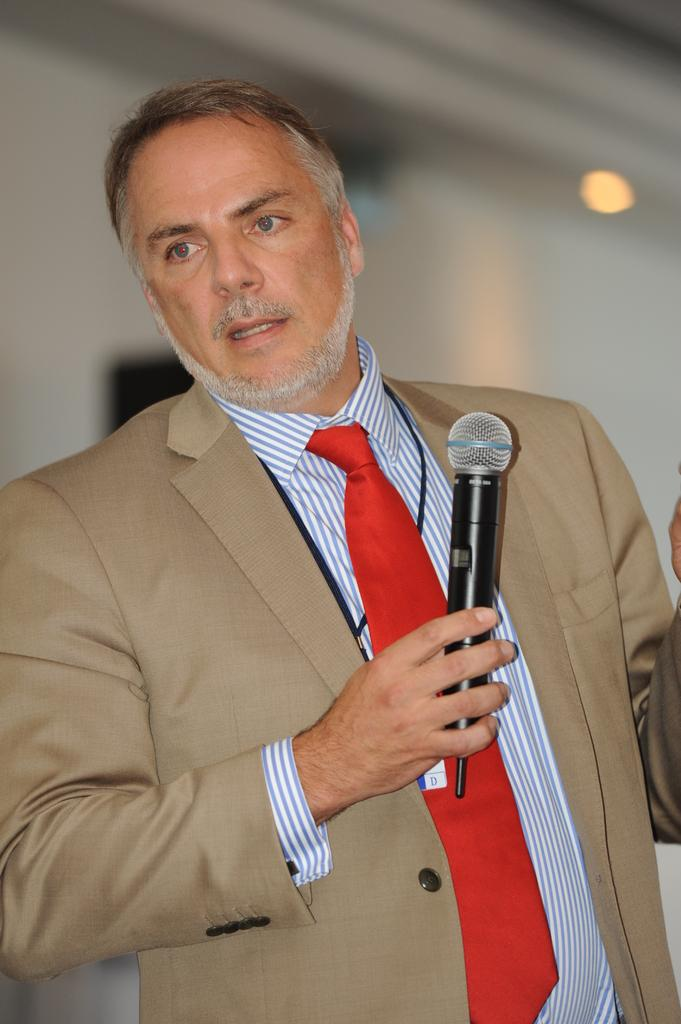Who is present in the image? There is a man in the image. What is the man wearing? The man is wearing a brown suit, a red tie, and a shirt. What is the man holding in the image? The man is holding a microphone. What can be seen in the background of the image? There is a white wall in the background, and there is light on the white wall. What type of paste is being used to draw on the street in the image? There is no street or paste present in the image; it features a man holding a microphone in front of a white wall. 